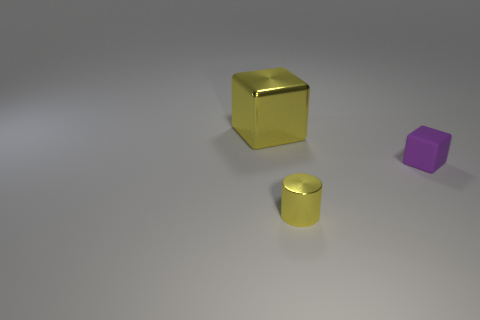Add 3 big gray matte cubes. How many objects exist? 6 Subtract all cylinders. How many objects are left? 2 Subtract all tiny brown shiny cylinders. Subtract all tiny yellow shiny things. How many objects are left? 2 Add 3 purple rubber cubes. How many purple rubber cubes are left? 4 Add 3 blue matte blocks. How many blue matte blocks exist? 3 Subtract 1 yellow cylinders. How many objects are left? 2 